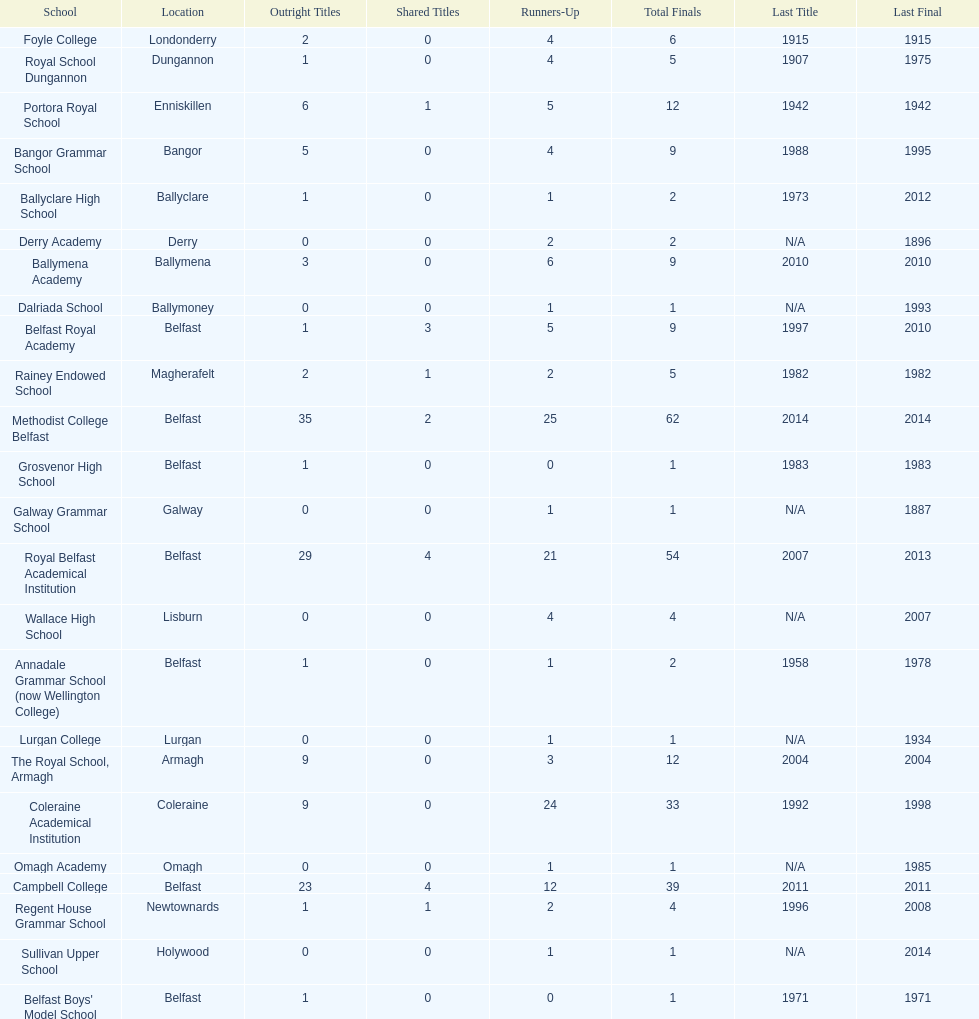When was the most recent year the regent house grammar school claimed a title? 1996. 